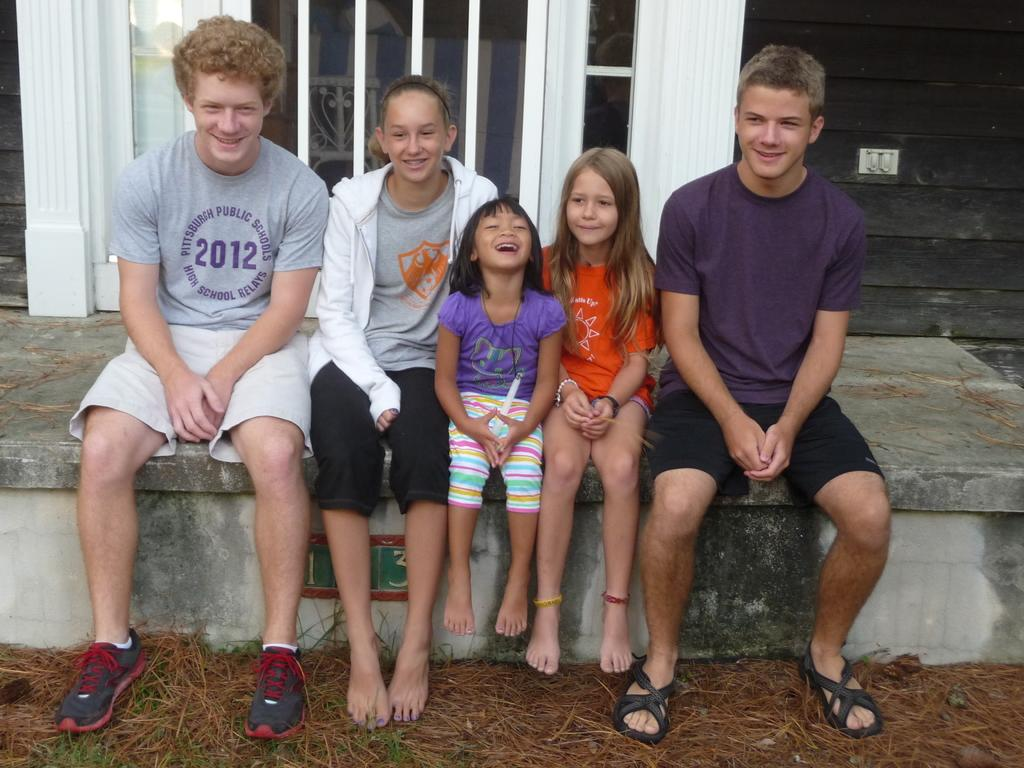What are the people in the image doing? The persons in the image are sitting on the pavement. What can be seen in the background of the image? There is an electric notch and windows in the background. What is the ground like in the image? The ground is visible in the background. What type of pickle is being used as a prop in the image? There is no pickle present in the image. What effect does the electric notch have on the people sitting on the pavement? The electric notch is in the background and does not have any direct effect on the people sitting on the pavement. 